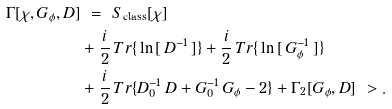Convert formula to latex. <formula><loc_0><loc_0><loc_500><loc_500>\Gamma [ \chi , G _ { \phi } , D ] & \ = \ S _ { \text {class} } [ \chi ] \\ & + \frac { i } { 2 } \, T r \{ \, \ln \, [ \, D ^ { - 1 } \, ] \} + \frac { i } { 2 } \, T r \{ \, \ln \, [ \, G _ { \phi } ^ { - 1 } \, ] \} \\ & + \frac { i } { 2 } \, T r \{ D _ { 0 } ^ { - 1 } \, D + G _ { 0 } ^ { - 1 } \, G _ { \phi } - 2 \} + \Gamma _ { 2 } [ G _ { \phi } , D ] \ > .</formula> 